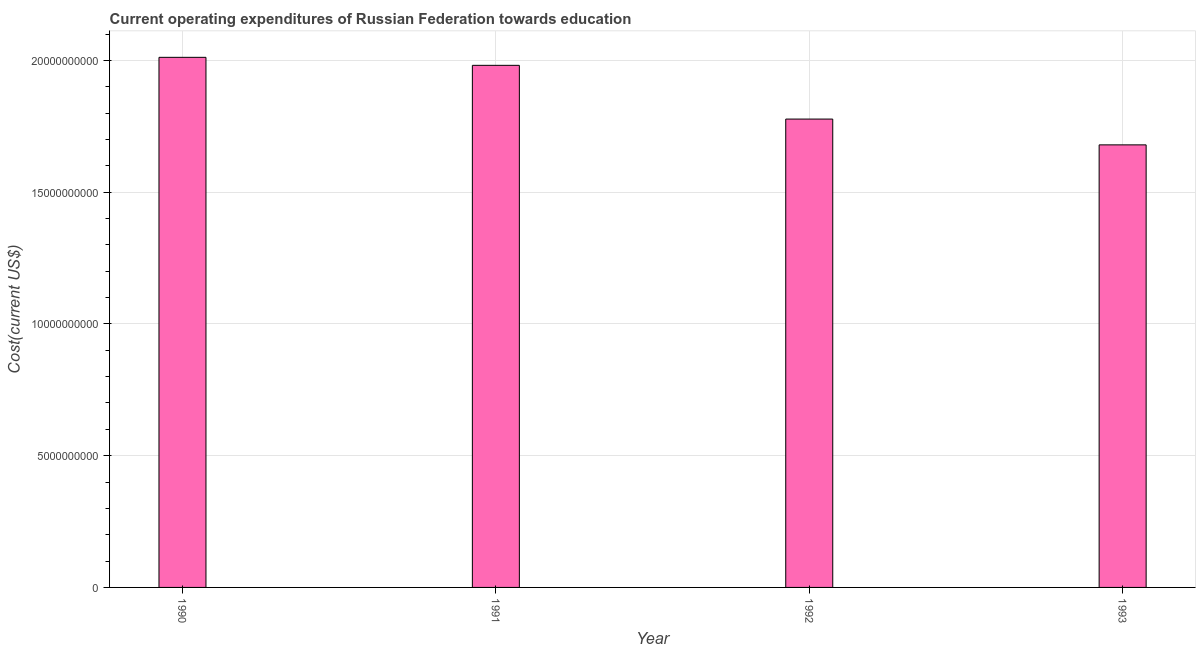Does the graph contain any zero values?
Make the answer very short. No. What is the title of the graph?
Keep it short and to the point. Current operating expenditures of Russian Federation towards education. What is the label or title of the X-axis?
Offer a terse response. Year. What is the label or title of the Y-axis?
Offer a terse response. Cost(current US$). What is the education expenditure in 1993?
Ensure brevity in your answer.  1.68e+1. Across all years, what is the maximum education expenditure?
Keep it short and to the point. 2.01e+1. Across all years, what is the minimum education expenditure?
Offer a terse response. 1.68e+1. What is the sum of the education expenditure?
Your answer should be very brief. 7.45e+1. What is the difference between the education expenditure in 1991 and 1992?
Provide a succinct answer. 2.04e+09. What is the average education expenditure per year?
Provide a short and direct response. 1.86e+1. What is the median education expenditure?
Provide a succinct answer. 1.88e+1. In how many years, is the education expenditure greater than 15000000000 US$?
Keep it short and to the point. 4. What is the ratio of the education expenditure in 1990 to that in 1992?
Provide a succinct answer. 1.13. Is the education expenditure in 1990 less than that in 1991?
Your answer should be very brief. No. Is the difference between the education expenditure in 1992 and 1993 greater than the difference between any two years?
Your response must be concise. No. What is the difference between the highest and the second highest education expenditure?
Provide a short and direct response. 3.04e+08. Is the sum of the education expenditure in 1990 and 1991 greater than the maximum education expenditure across all years?
Your answer should be compact. Yes. What is the difference between the highest and the lowest education expenditure?
Offer a terse response. 3.32e+09. How many bars are there?
Give a very brief answer. 4. How many years are there in the graph?
Offer a very short reply. 4. What is the Cost(current US$) in 1990?
Make the answer very short. 2.01e+1. What is the Cost(current US$) in 1991?
Offer a terse response. 1.98e+1. What is the Cost(current US$) of 1992?
Offer a terse response. 1.78e+1. What is the Cost(current US$) in 1993?
Ensure brevity in your answer.  1.68e+1. What is the difference between the Cost(current US$) in 1990 and 1991?
Ensure brevity in your answer.  3.04e+08. What is the difference between the Cost(current US$) in 1990 and 1992?
Your response must be concise. 2.34e+09. What is the difference between the Cost(current US$) in 1990 and 1993?
Ensure brevity in your answer.  3.32e+09. What is the difference between the Cost(current US$) in 1991 and 1992?
Offer a terse response. 2.04e+09. What is the difference between the Cost(current US$) in 1991 and 1993?
Offer a very short reply. 3.02e+09. What is the difference between the Cost(current US$) in 1992 and 1993?
Your response must be concise. 9.79e+08. What is the ratio of the Cost(current US$) in 1990 to that in 1992?
Your response must be concise. 1.13. What is the ratio of the Cost(current US$) in 1990 to that in 1993?
Provide a succinct answer. 1.2. What is the ratio of the Cost(current US$) in 1991 to that in 1992?
Your response must be concise. 1.11. What is the ratio of the Cost(current US$) in 1991 to that in 1993?
Provide a short and direct response. 1.18. What is the ratio of the Cost(current US$) in 1992 to that in 1993?
Make the answer very short. 1.06. 